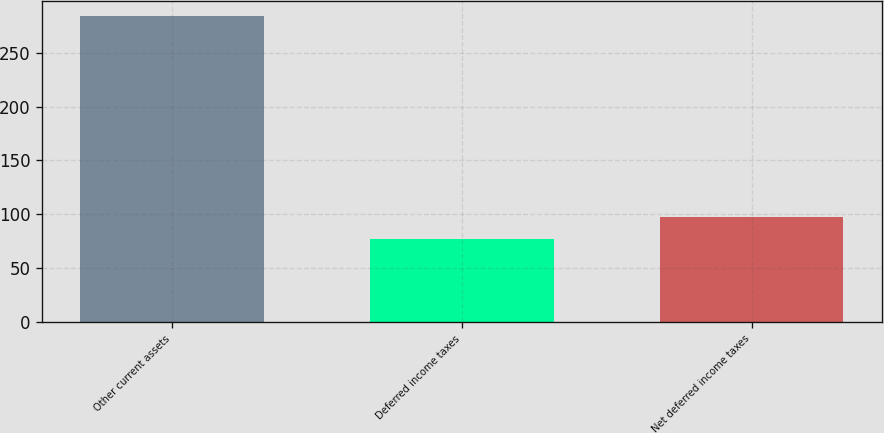Convert chart to OTSL. <chart><loc_0><loc_0><loc_500><loc_500><bar_chart><fcel>Other current assets<fcel>Deferred income taxes<fcel>Net deferred income taxes<nl><fcel>284<fcel>77<fcel>97.7<nl></chart> 